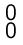<formula> <loc_0><loc_0><loc_500><loc_500>\begin{smallmatrix} 0 \\ 0 \\ \end{smallmatrix}</formula> 